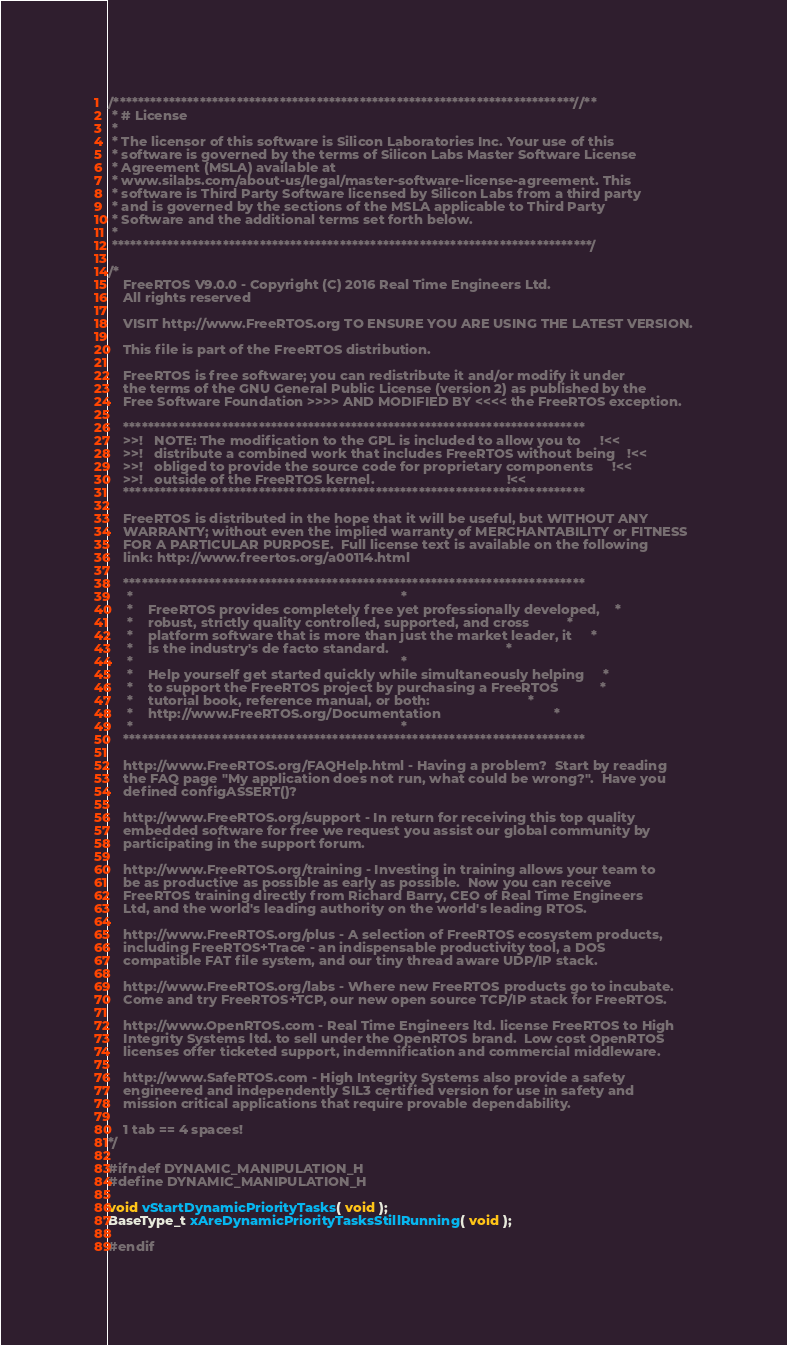Convert code to text. <code><loc_0><loc_0><loc_500><loc_500><_C_>/***************************************************************************//**
 * # License
 * 
 * The licensor of this software is Silicon Laboratories Inc. Your use of this
 * software is governed by the terms of Silicon Labs Master Software License
 * Agreement (MSLA) available at
 * www.silabs.com/about-us/legal/master-software-license-agreement. This
 * software is Third Party Software licensed by Silicon Labs from a third party
 * and is governed by the sections of the MSLA applicable to Third Party
 * Software and the additional terms set forth below.
 * 
 ******************************************************************************/

/*
    FreeRTOS V9.0.0 - Copyright (C) 2016 Real Time Engineers Ltd.
    All rights reserved

    VISIT http://www.FreeRTOS.org TO ENSURE YOU ARE USING THE LATEST VERSION.

    This file is part of the FreeRTOS distribution.

    FreeRTOS is free software; you can redistribute it and/or modify it under
    the terms of the GNU General Public License (version 2) as published by the
    Free Software Foundation >>>> AND MODIFIED BY <<<< the FreeRTOS exception.

    ***************************************************************************
    >>!   NOTE: The modification to the GPL is included to allow you to     !<<
    >>!   distribute a combined work that includes FreeRTOS without being   !<<
    >>!   obliged to provide the source code for proprietary components     !<<
    >>!   outside of the FreeRTOS kernel.                                   !<<
    ***************************************************************************

    FreeRTOS is distributed in the hope that it will be useful, but WITHOUT ANY
    WARRANTY; without even the implied warranty of MERCHANTABILITY or FITNESS
    FOR A PARTICULAR PURPOSE.  Full license text is available on the following
    link: http://www.freertos.org/a00114.html

    ***************************************************************************
     *                                                                       *
     *    FreeRTOS provides completely free yet professionally developed,    *
     *    robust, strictly quality controlled, supported, and cross          *
     *    platform software that is more than just the market leader, it     *
     *    is the industry's de facto standard.                               *
     *                                                                       *
     *    Help yourself get started quickly while simultaneously helping     *
     *    to support the FreeRTOS project by purchasing a FreeRTOS           *
     *    tutorial book, reference manual, or both:                          *
     *    http://www.FreeRTOS.org/Documentation                              *
     *                                                                       *
    ***************************************************************************

    http://www.FreeRTOS.org/FAQHelp.html - Having a problem?  Start by reading
    the FAQ page "My application does not run, what could be wrong?".  Have you
    defined configASSERT()?

    http://www.FreeRTOS.org/support - In return for receiving this top quality
    embedded software for free we request you assist our global community by
    participating in the support forum.

    http://www.FreeRTOS.org/training - Investing in training allows your team to
    be as productive as possible as early as possible.  Now you can receive
    FreeRTOS training directly from Richard Barry, CEO of Real Time Engineers
    Ltd, and the world's leading authority on the world's leading RTOS.

    http://www.FreeRTOS.org/plus - A selection of FreeRTOS ecosystem products,
    including FreeRTOS+Trace - an indispensable productivity tool, a DOS
    compatible FAT file system, and our tiny thread aware UDP/IP stack.

    http://www.FreeRTOS.org/labs - Where new FreeRTOS products go to incubate.
    Come and try FreeRTOS+TCP, our new open source TCP/IP stack for FreeRTOS.

    http://www.OpenRTOS.com - Real Time Engineers ltd. license FreeRTOS to High
    Integrity Systems ltd. to sell under the OpenRTOS brand.  Low cost OpenRTOS
    licenses offer ticketed support, indemnification and commercial middleware.

    http://www.SafeRTOS.com - High Integrity Systems also provide a safety
    engineered and independently SIL3 certified version for use in safety and
    mission critical applications that require provable dependability.

    1 tab == 4 spaces!
*/

#ifndef DYNAMIC_MANIPULATION_H
#define DYNAMIC_MANIPULATION_H

void vStartDynamicPriorityTasks( void );
BaseType_t xAreDynamicPriorityTasksStillRunning( void );

#endif


</code> 